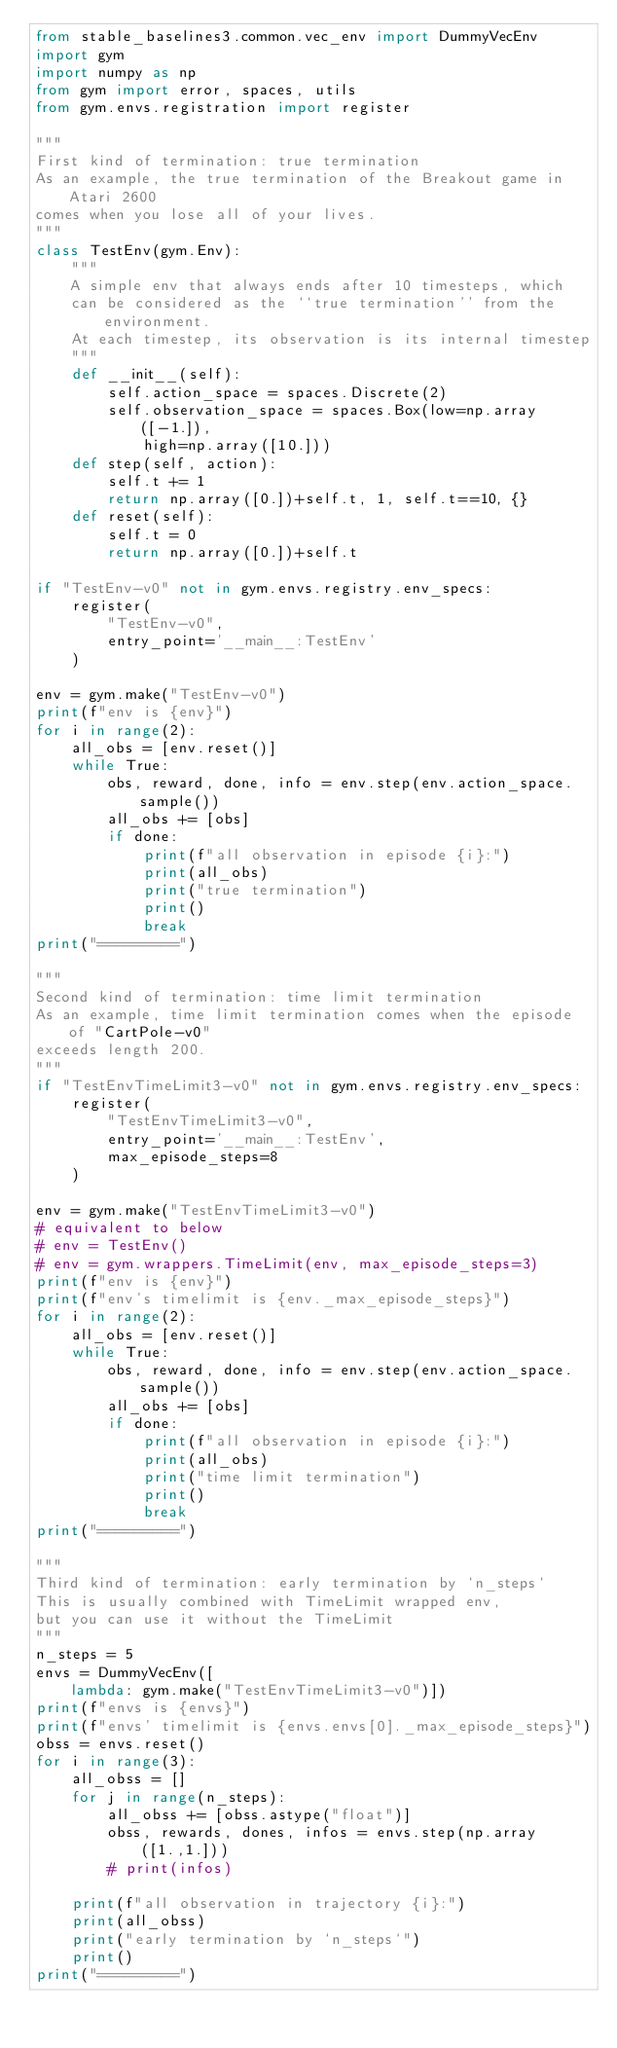<code> <loc_0><loc_0><loc_500><loc_500><_Python_>from stable_baselines3.common.vec_env import DummyVecEnv
import gym
import numpy as np
from gym import error, spaces, utils
from gym.envs.registration import register

"""
First kind of termination: true termination
As an example, the true termination of the Breakout game in Atari 2600
comes when you lose all of your lives.
"""
class TestEnv(gym.Env):
    """
    A simple env that always ends after 10 timesteps, which 
    can be considered as the ``true termination'' from the environment.
    At each timestep, its observation is its internal timestep
    """
    def __init__(self):
        self.action_space = spaces.Discrete(2)
        self.observation_space = spaces.Box(low=np.array([-1.]),
            high=np.array([10.]))
    def step(self, action):
        self.t += 1
        return np.array([0.])+self.t, 1, self.t==10, {}
    def reset(self):
        self.t = 0
        return np.array([0.])+self.t

if "TestEnv-v0" not in gym.envs.registry.env_specs:
    register(
        "TestEnv-v0",
        entry_point='__main__:TestEnv'
    )

env = gym.make("TestEnv-v0")
print(f"env is {env}")
for i in range(2):
    all_obs = [env.reset()]
    while True:
        obs, reward, done, info = env.step(env.action_space.sample())
        all_obs += [obs]
        if done:
            print(f"all observation in episode {i}:")
            print(all_obs)
            print("true termination")
            print()
            break
print("=========")

"""
Second kind of termination: time limit termination
As an example, time limit termination comes when the episode of "CartPole-v0"
exceeds length 200.
"""
if "TestEnvTimeLimit3-v0" not in gym.envs.registry.env_specs:
    register(
        "TestEnvTimeLimit3-v0",
        entry_point='__main__:TestEnv',
        max_episode_steps=8
    )

env = gym.make("TestEnvTimeLimit3-v0")
# equivalent to below
# env = TestEnv()
# env = gym.wrappers.TimeLimit(env, max_episode_steps=3)
print(f"env is {env}")
print(f"env's timelimit is {env._max_episode_steps}")
for i in range(2):
    all_obs = [env.reset()]
    while True:
        obs, reward, done, info = env.step(env.action_space.sample())
        all_obs += [obs]
        if done:
            print(f"all observation in episode {i}:")
            print(all_obs)
            print("time limit termination")
            print()
            break
print("=========")

"""
Third kind of termination: early termination by `n_steps`
This is usually combined with TimeLimit wrapped env,
but you can use it without the TimeLimit
"""
n_steps = 5
envs = DummyVecEnv([
    lambda: gym.make("TestEnvTimeLimit3-v0")])
print(f"envs is {envs}")
print(f"envs' timelimit is {envs.envs[0]._max_episode_steps}")
obss = envs.reset()
for i in range(3):
    all_obss = []
    for j in range(n_steps):
        all_obss += [obss.astype("float")]
        obss, rewards, dones, infos = envs.step(np.array([1.,1.]))
        # print(infos)
    
    print(f"all observation in trajectory {i}:")
    print(all_obss)
    print("early termination by `n_steps`")
    print()
print("=========")</code> 